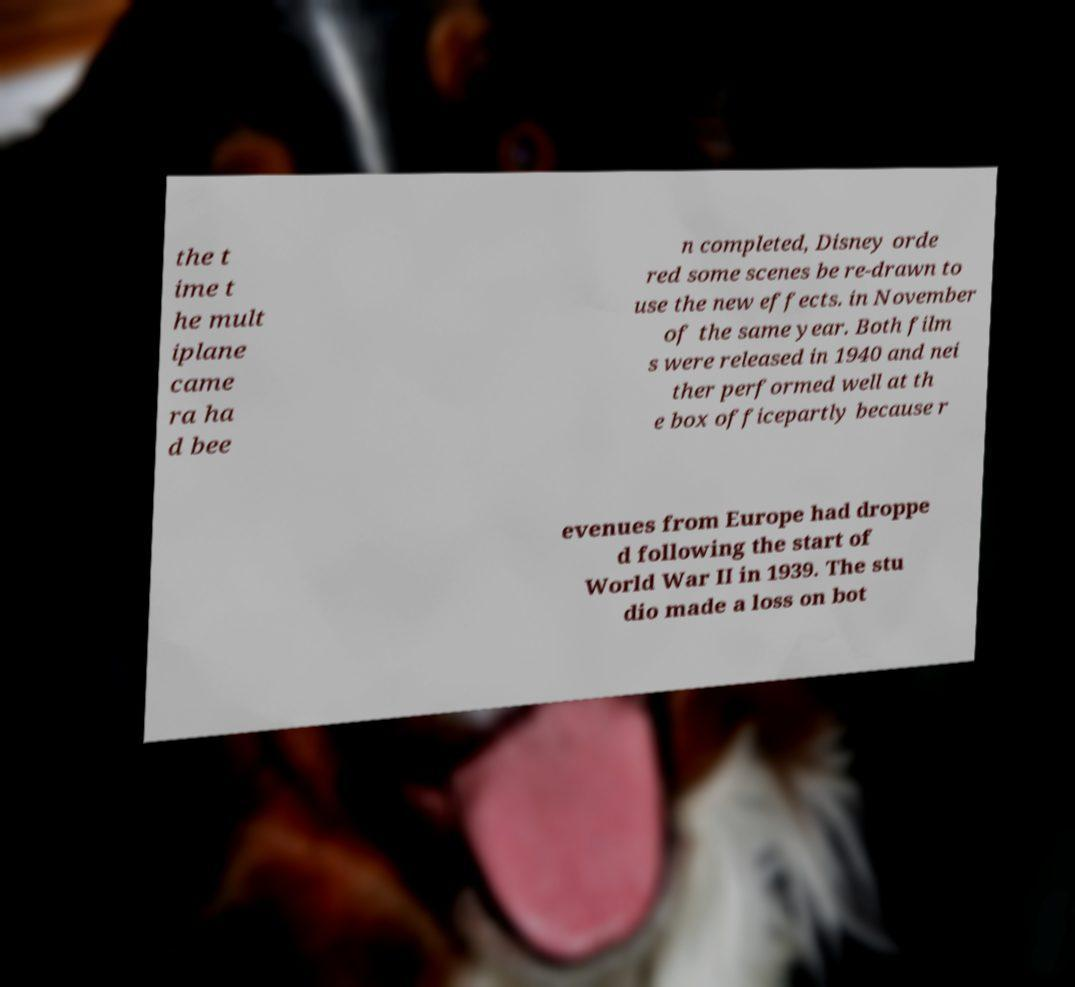Can you read and provide the text displayed in the image?This photo seems to have some interesting text. Can you extract and type it out for me? the t ime t he mult iplane came ra ha d bee n completed, Disney orde red some scenes be re-drawn to use the new effects. in November of the same year. Both film s were released in 1940 and nei ther performed well at th e box officepartly because r evenues from Europe had droppe d following the start of World War II in 1939. The stu dio made a loss on bot 